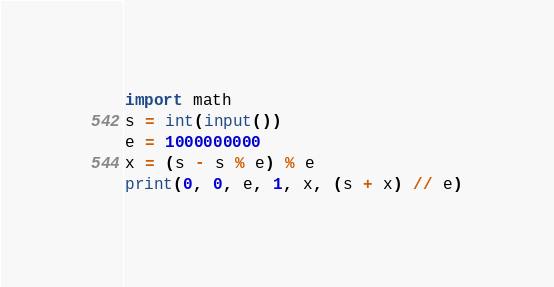<code> <loc_0><loc_0><loc_500><loc_500><_Python_>import math
s = int(input())
e = 1000000000
x = (s - s % e) % e
print(0, 0, e, 1, x, (s + x) // e)</code> 